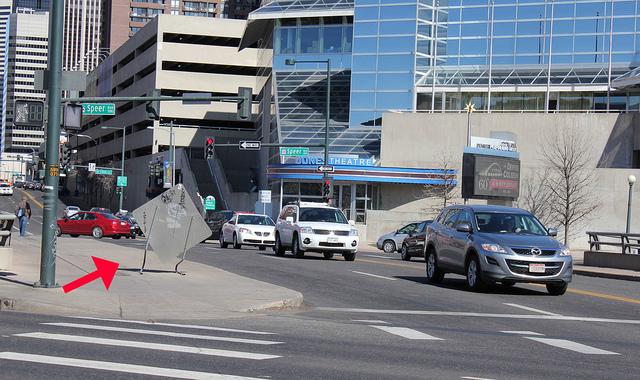Is it ok for vehicles to make a left turn?
Answer briefly. Yes. Are there any balconies?
Short answer required. No. What is in motion?
Concise answer only. Cars. How many cars are in the picture?
Concise answer only. 10. Where is the arrow pointing?
Keep it brief. Right. Is this a night time scent?
Keep it brief. No. Is this scene in the country?
Write a very short answer. No. Are the cars moving?
Be succinct. Yes. What does the lettering on the car say?
Give a very brief answer. Kia. Does this appear to be in the United States?
Be succinct. Yes. What is on the higher levels of these buildings?
Answer briefly. Windows. 